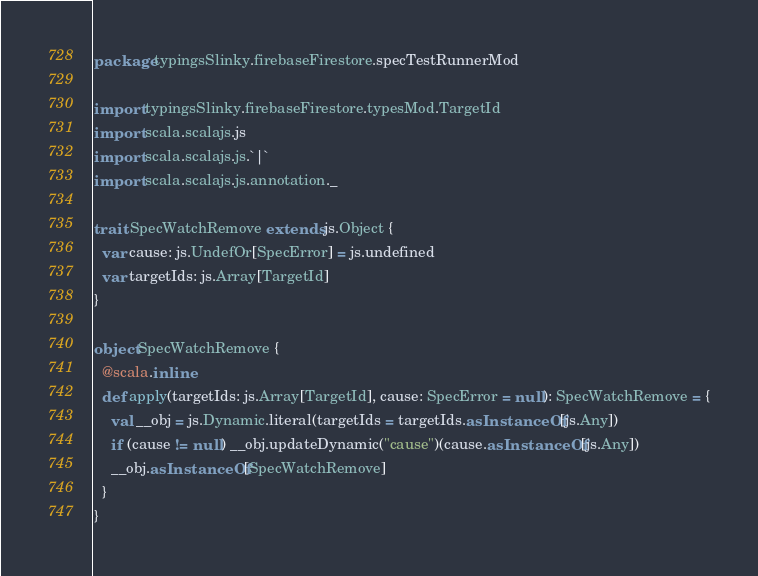Convert code to text. <code><loc_0><loc_0><loc_500><loc_500><_Scala_>package typingsSlinky.firebaseFirestore.specTestRunnerMod

import typingsSlinky.firebaseFirestore.typesMod.TargetId
import scala.scalajs.js
import scala.scalajs.js.`|`
import scala.scalajs.js.annotation._

trait SpecWatchRemove extends js.Object {
  var cause: js.UndefOr[SpecError] = js.undefined
  var targetIds: js.Array[TargetId]
}

object SpecWatchRemove {
  @scala.inline
  def apply(targetIds: js.Array[TargetId], cause: SpecError = null): SpecWatchRemove = {
    val __obj = js.Dynamic.literal(targetIds = targetIds.asInstanceOf[js.Any])
    if (cause != null) __obj.updateDynamic("cause")(cause.asInstanceOf[js.Any])
    __obj.asInstanceOf[SpecWatchRemove]
  }
}

</code> 